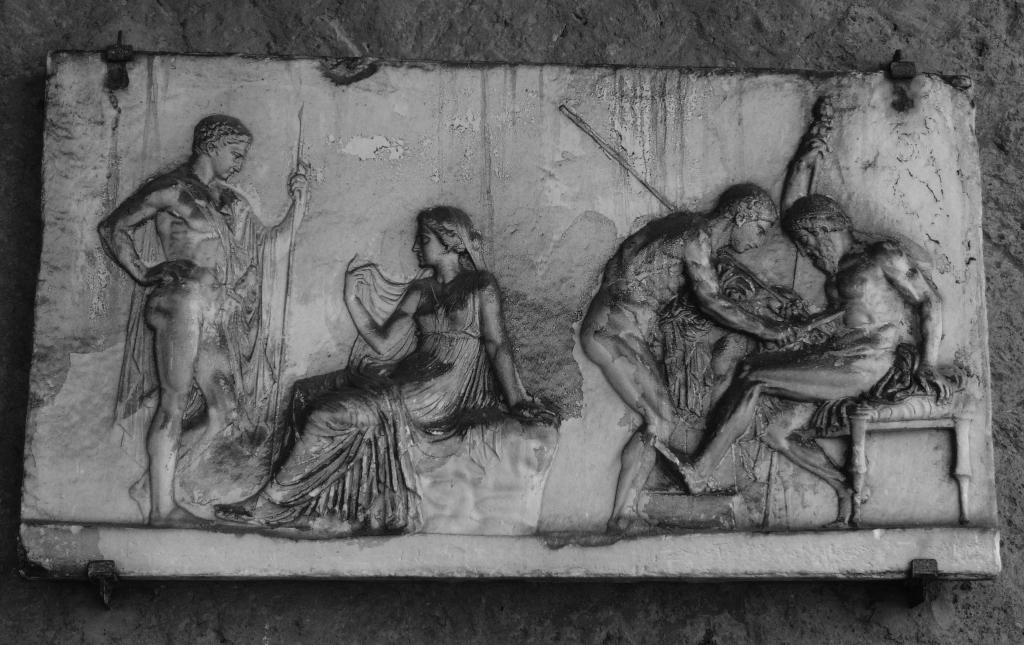What is depicted on the wall in the image? There is a carving of persons on a wall in the image. What color scheme is used in the image? The image is black and white. What type of orange is being peeled in the image? There is no orange present in the image; it features a carving of persons on a wall in black and white. What holiday is being celebrated in the image? The image does not depict a holiday or any celebratory event. 